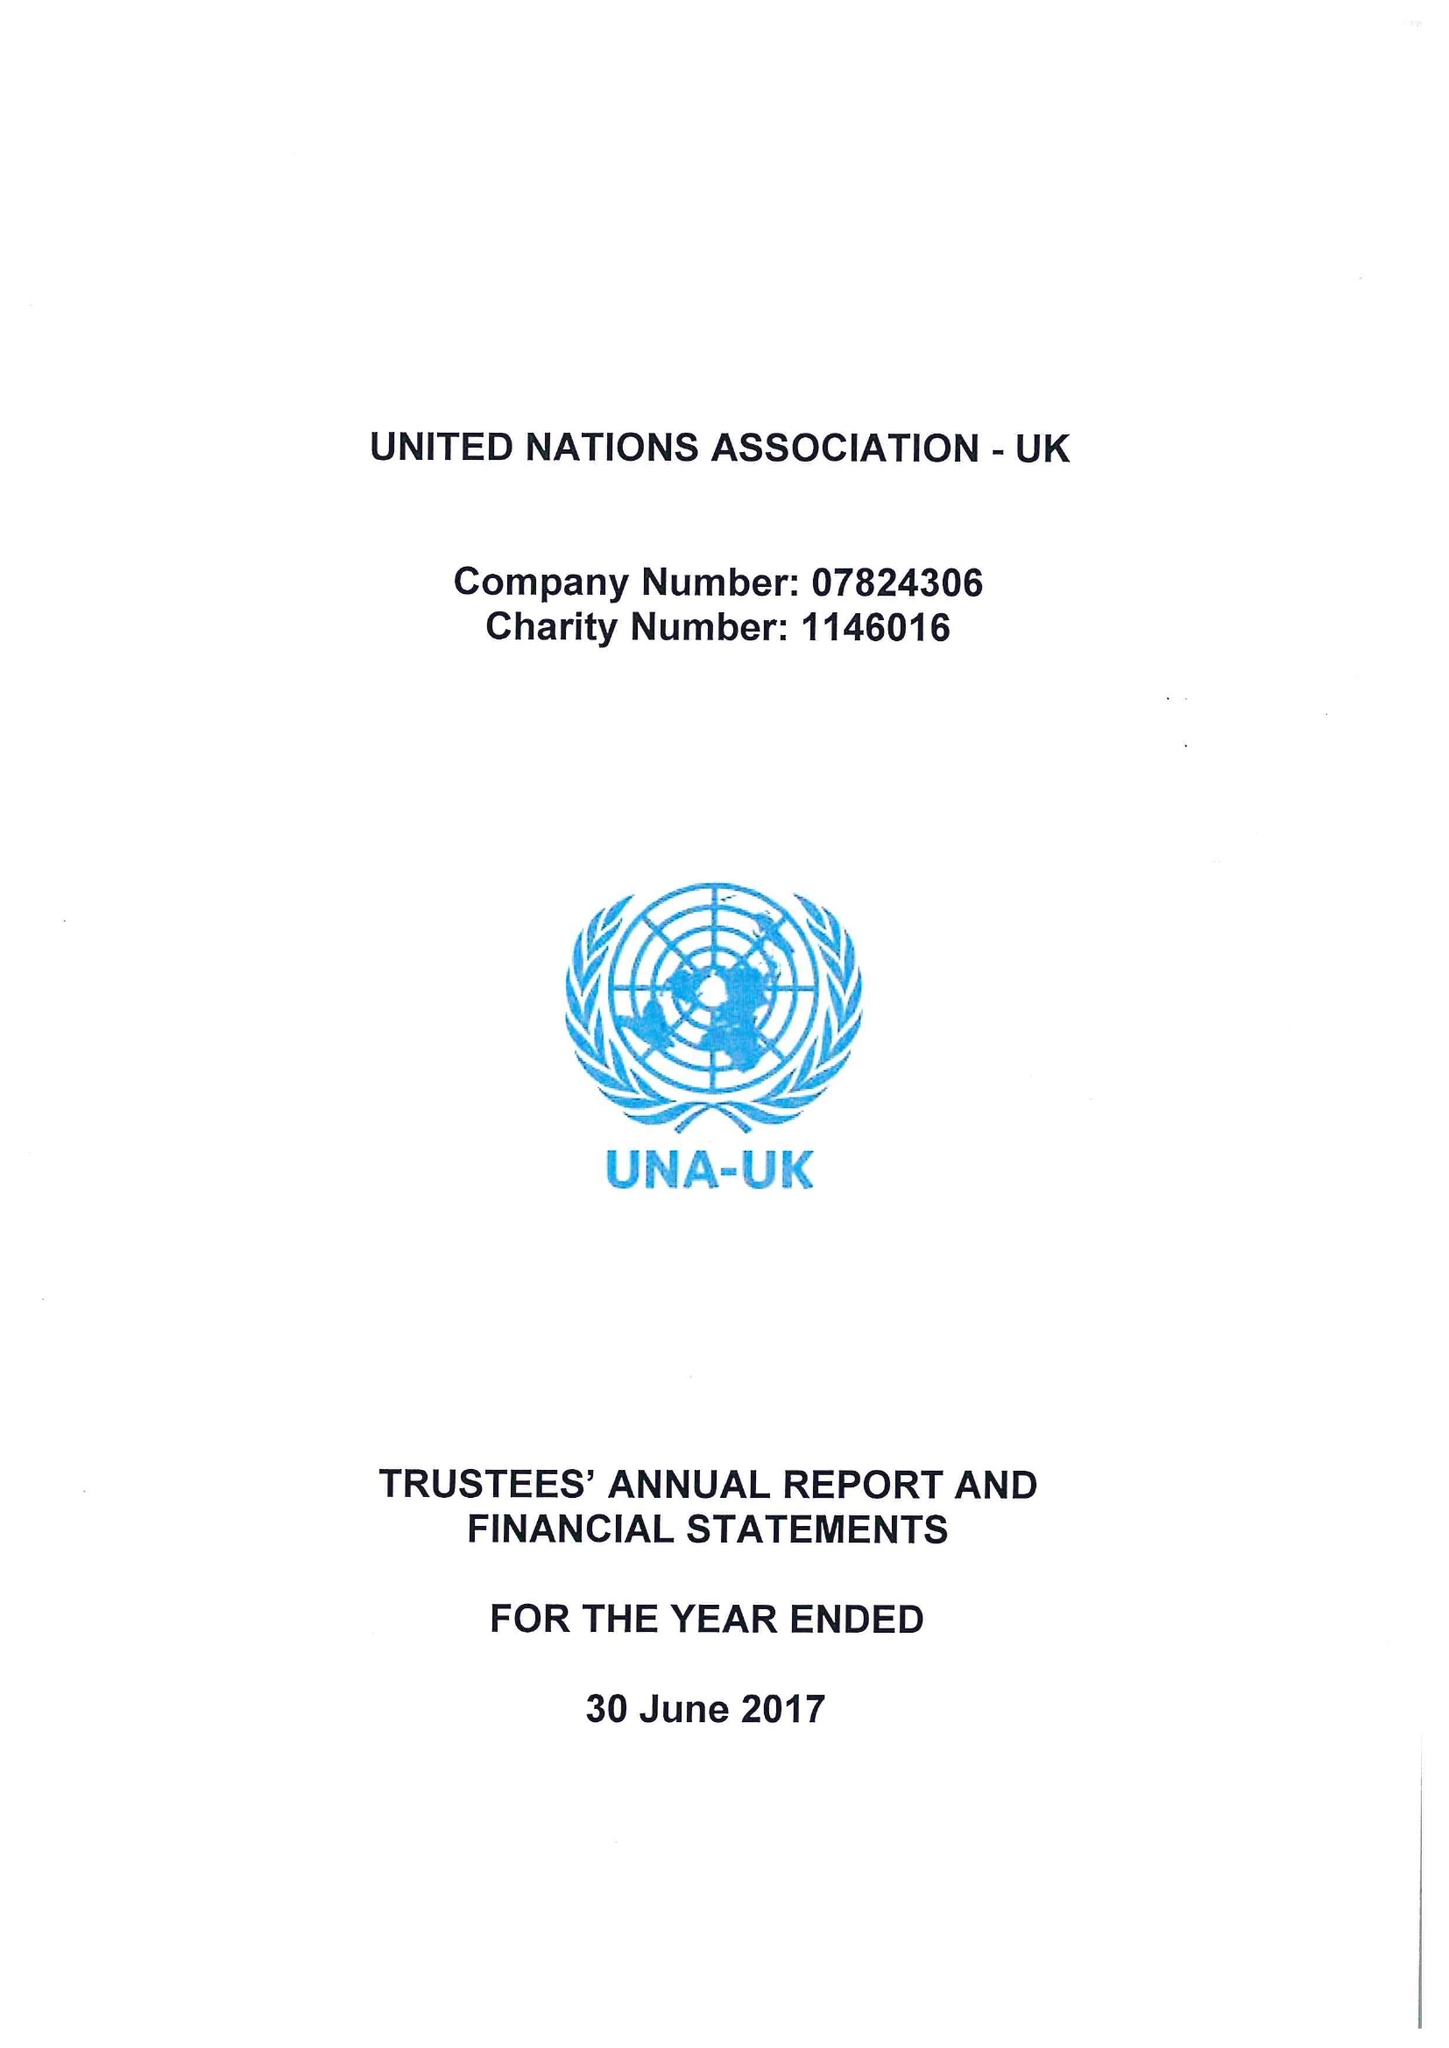What is the value for the charity_number?
Answer the question using a single word or phrase. 1146016 